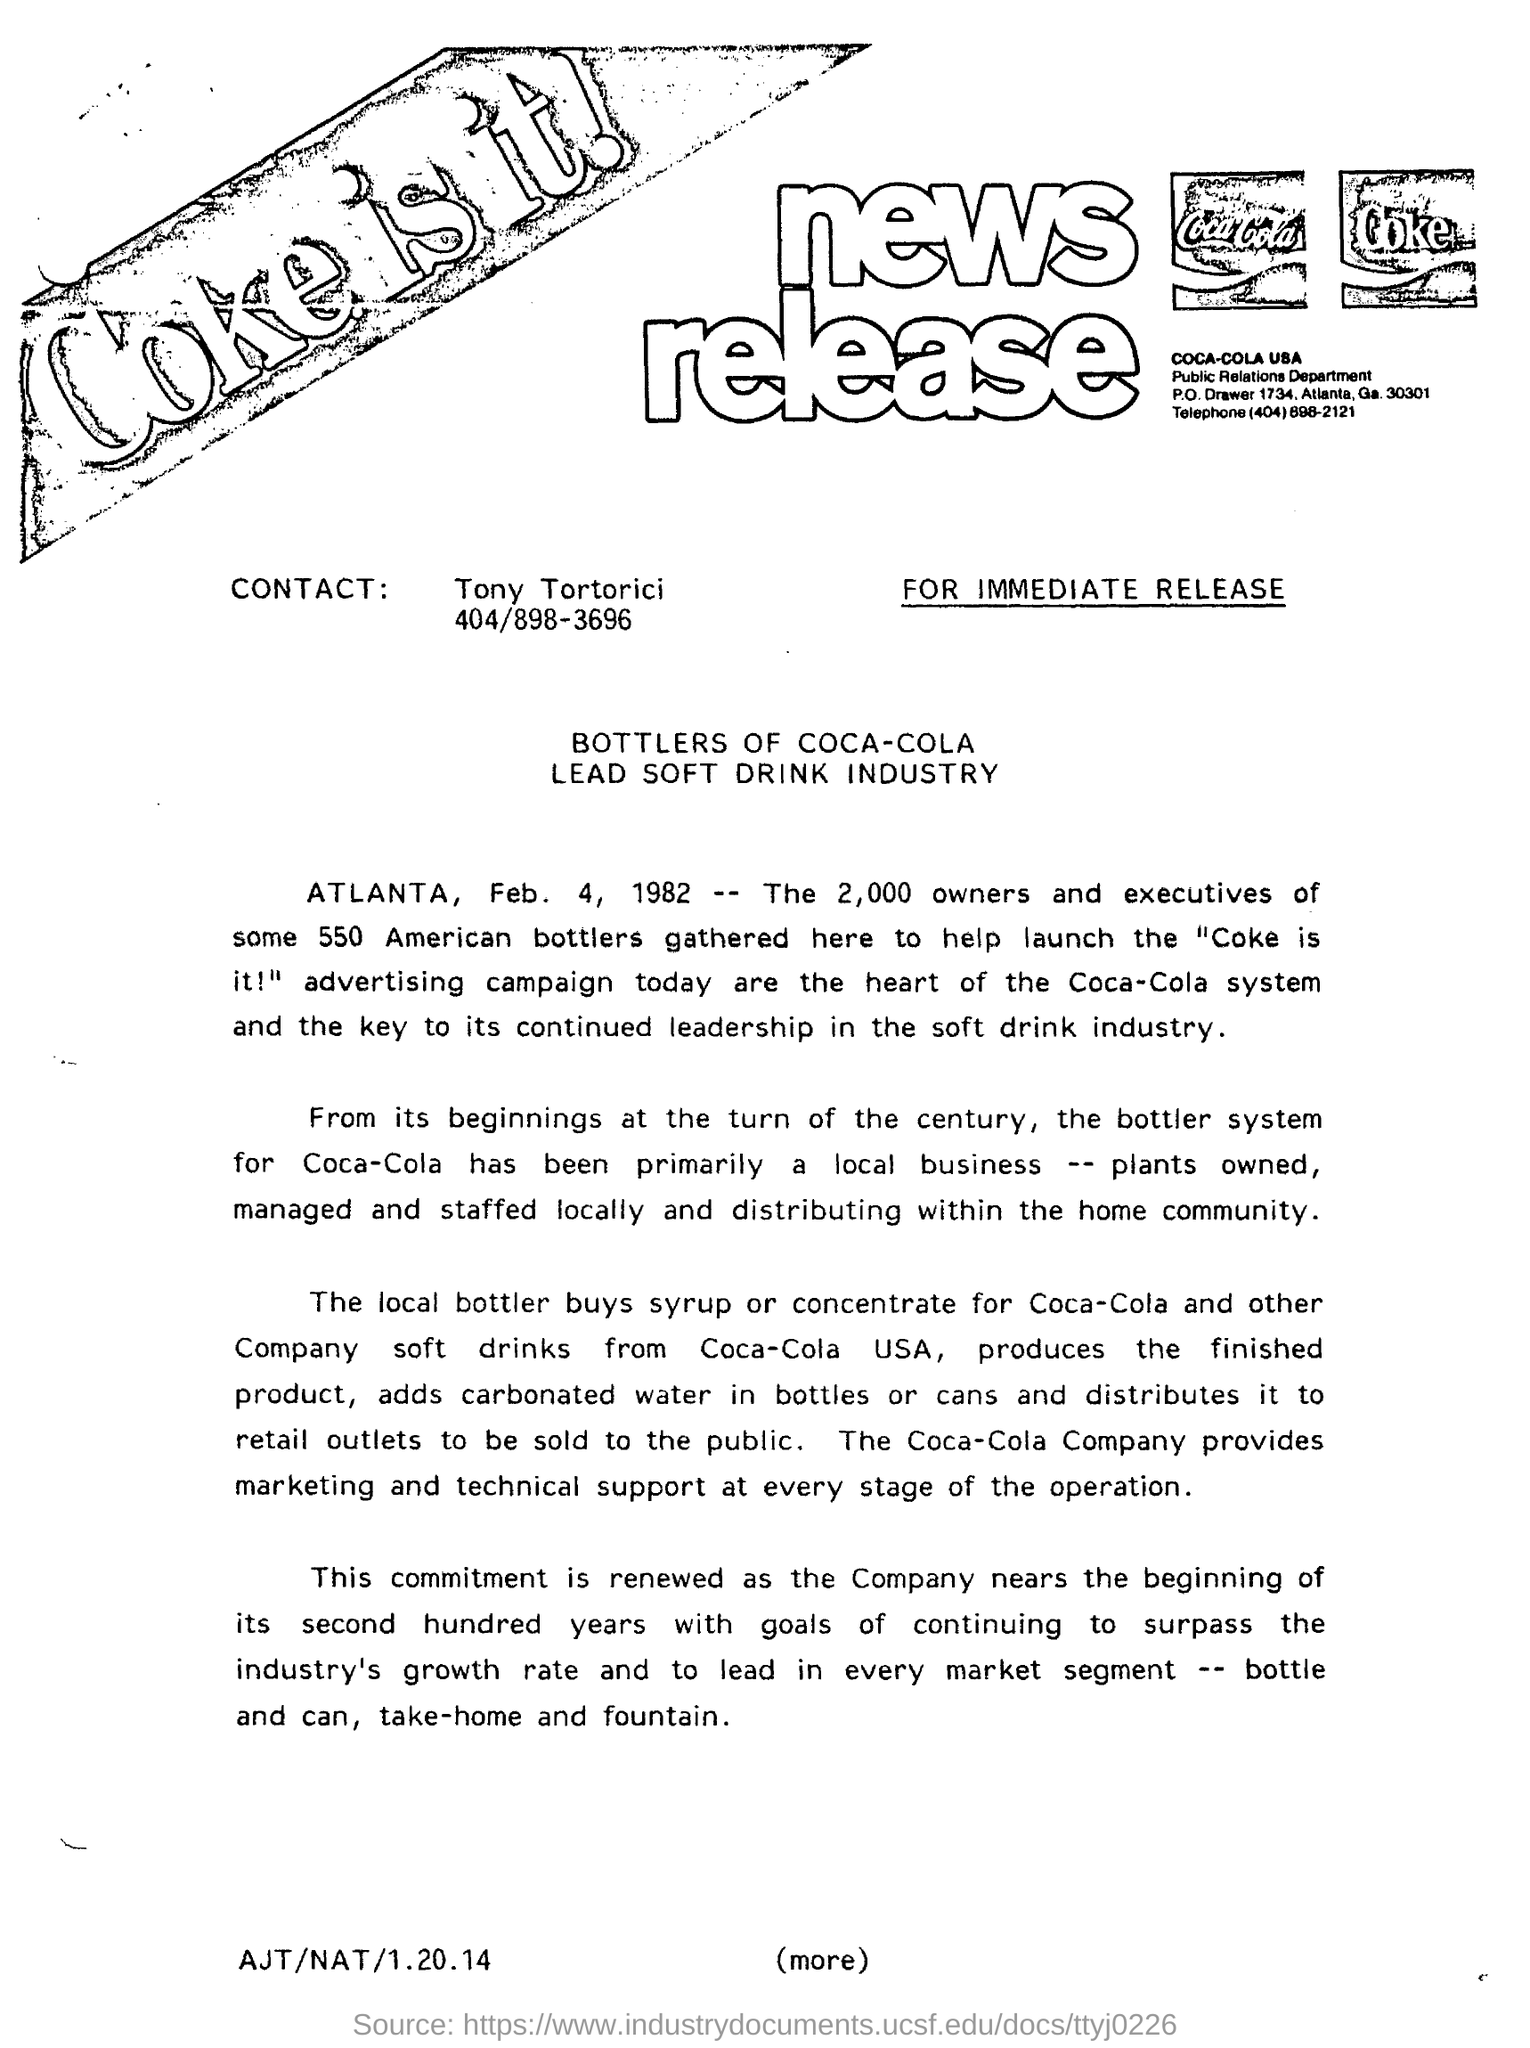Identify some key points in this picture. The Coca-Cola Company provides marketing and technical support at every stage of operation, ensuring a seamless and successful experience for its clients. The contact number of Tony Tortorici is 404/898-3696. The headline of the news release is that bottlers of Coca-Cola are leading the soft drink industry. The contact person mentioned in the document is Tony Tortorici. 